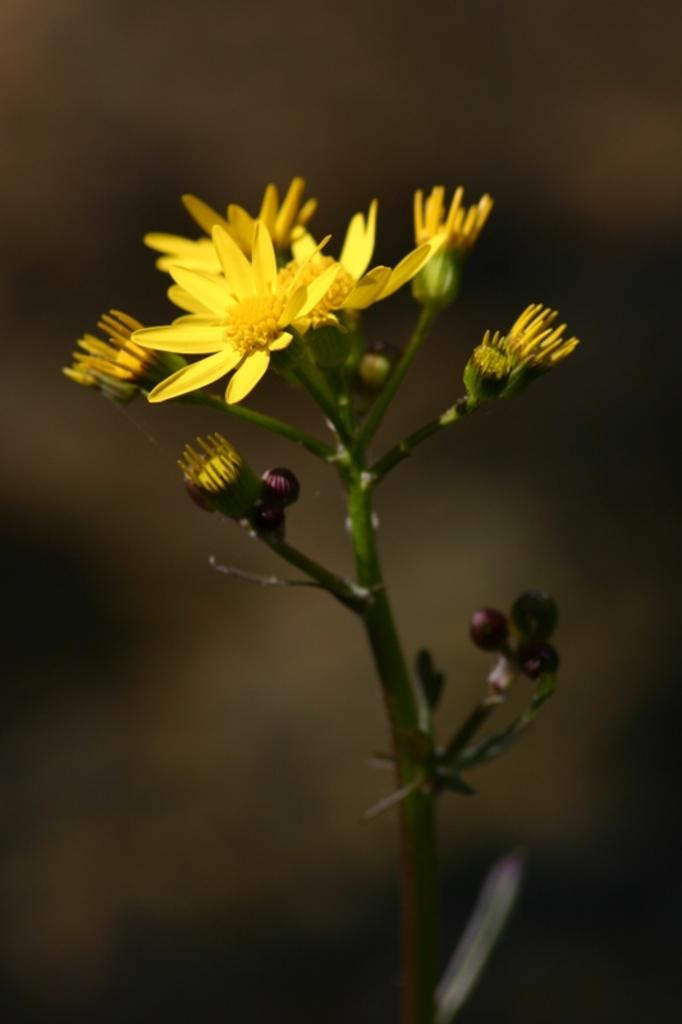What is the main subject of the image? There is a plant in the center of the image. What are the characteristics of the plant? The plant has flowers and buds. Can you describe the background of the image? The background of the image is blurred. How many chickens are present in the image? There are no chickens present in the image; it features a plant with flowers and buds. What advice does the father give in the image? There is no father or advice present in the image; it is a photograph of a plant. 